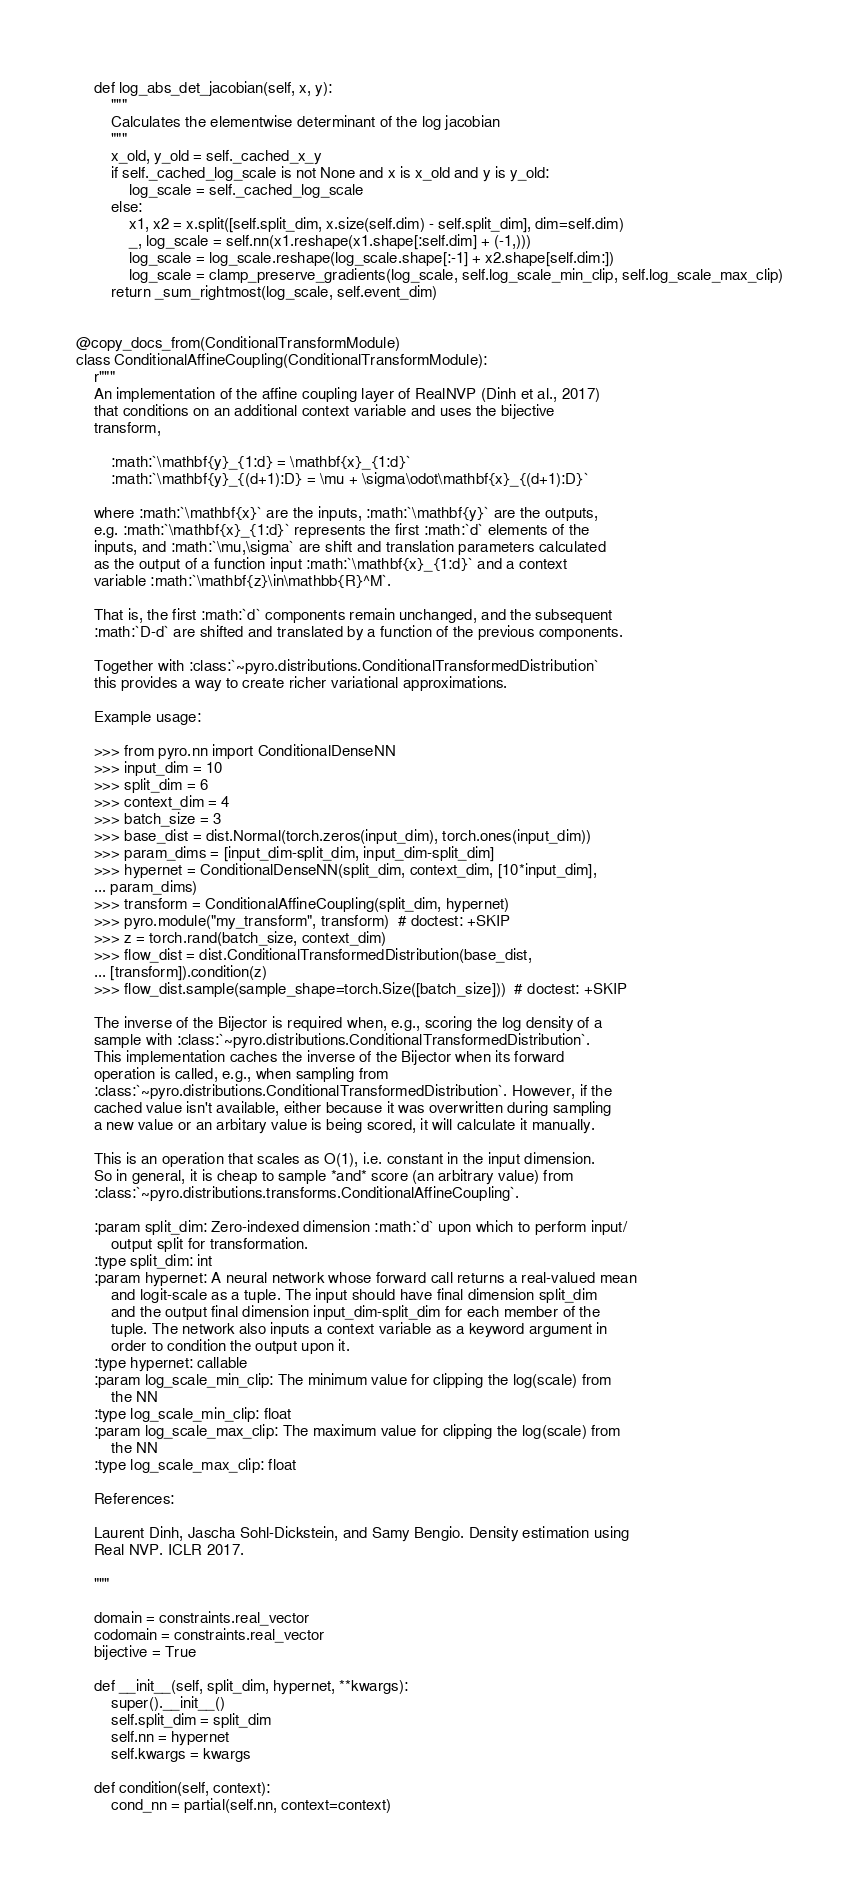Convert code to text. <code><loc_0><loc_0><loc_500><loc_500><_Python_>    def log_abs_det_jacobian(self, x, y):
        """
        Calculates the elementwise determinant of the log jacobian
        """
        x_old, y_old = self._cached_x_y
        if self._cached_log_scale is not None and x is x_old and y is y_old:
            log_scale = self._cached_log_scale
        else:
            x1, x2 = x.split([self.split_dim, x.size(self.dim) - self.split_dim], dim=self.dim)
            _, log_scale = self.nn(x1.reshape(x1.shape[:self.dim] + (-1,)))
            log_scale = log_scale.reshape(log_scale.shape[:-1] + x2.shape[self.dim:])
            log_scale = clamp_preserve_gradients(log_scale, self.log_scale_min_clip, self.log_scale_max_clip)
        return _sum_rightmost(log_scale, self.event_dim)


@copy_docs_from(ConditionalTransformModule)
class ConditionalAffineCoupling(ConditionalTransformModule):
    r"""
    An implementation of the affine coupling layer of RealNVP (Dinh et al., 2017)
    that conditions on an additional context variable and uses the bijective
    transform,

        :math:`\mathbf{y}_{1:d} = \mathbf{x}_{1:d}`
        :math:`\mathbf{y}_{(d+1):D} = \mu + \sigma\odot\mathbf{x}_{(d+1):D}`

    where :math:`\mathbf{x}` are the inputs, :math:`\mathbf{y}` are the outputs,
    e.g. :math:`\mathbf{x}_{1:d}` represents the first :math:`d` elements of the
    inputs, and :math:`\mu,\sigma` are shift and translation parameters calculated
    as the output of a function input :math:`\mathbf{x}_{1:d}` and a context
    variable :math:`\mathbf{z}\in\mathbb{R}^M`.

    That is, the first :math:`d` components remain unchanged, and the subsequent
    :math:`D-d` are shifted and translated by a function of the previous components.

    Together with :class:`~pyro.distributions.ConditionalTransformedDistribution`
    this provides a way to create richer variational approximations.

    Example usage:

    >>> from pyro.nn import ConditionalDenseNN
    >>> input_dim = 10
    >>> split_dim = 6
    >>> context_dim = 4
    >>> batch_size = 3
    >>> base_dist = dist.Normal(torch.zeros(input_dim), torch.ones(input_dim))
    >>> param_dims = [input_dim-split_dim, input_dim-split_dim]
    >>> hypernet = ConditionalDenseNN(split_dim, context_dim, [10*input_dim],
    ... param_dims)
    >>> transform = ConditionalAffineCoupling(split_dim, hypernet)
    >>> pyro.module("my_transform", transform)  # doctest: +SKIP
    >>> z = torch.rand(batch_size, context_dim)
    >>> flow_dist = dist.ConditionalTransformedDistribution(base_dist,
    ... [transform]).condition(z)
    >>> flow_dist.sample(sample_shape=torch.Size([batch_size]))  # doctest: +SKIP

    The inverse of the Bijector is required when, e.g., scoring the log density of a
    sample with :class:`~pyro.distributions.ConditionalTransformedDistribution`.
    This implementation caches the inverse of the Bijector when its forward
    operation is called, e.g., when sampling from
    :class:`~pyro.distributions.ConditionalTransformedDistribution`. However, if the
    cached value isn't available, either because it was overwritten during sampling
    a new value or an arbitary value is being scored, it will calculate it manually.

    This is an operation that scales as O(1), i.e. constant in the input dimension.
    So in general, it is cheap to sample *and* score (an arbitrary value) from
    :class:`~pyro.distributions.transforms.ConditionalAffineCoupling`.

    :param split_dim: Zero-indexed dimension :math:`d` upon which to perform input/
        output split for transformation.
    :type split_dim: int
    :param hypernet: A neural network whose forward call returns a real-valued mean
        and logit-scale as a tuple. The input should have final dimension split_dim
        and the output final dimension input_dim-split_dim for each member of the
        tuple. The network also inputs a context variable as a keyword argument in
        order to condition the output upon it.
    :type hypernet: callable
    :param log_scale_min_clip: The minimum value for clipping the log(scale) from
        the NN
    :type log_scale_min_clip: float
    :param log_scale_max_clip: The maximum value for clipping the log(scale) from
        the NN
    :type log_scale_max_clip: float

    References:

    Laurent Dinh, Jascha Sohl-Dickstein, and Samy Bengio. Density estimation using
    Real NVP. ICLR 2017.

    """

    domain = constraints.real_vector
    codomain = constraints.real_vector
    bijective = True

    def __init__(self, split_dim, hypernet, **kwargs):
        super().__init__()
        self.split_dim = split_dim
        self.nn = hypernet
        self.kwargs = kwargs

    def condition(self, context):
        cond_nn = partial(self.nn, context=context)</code> 